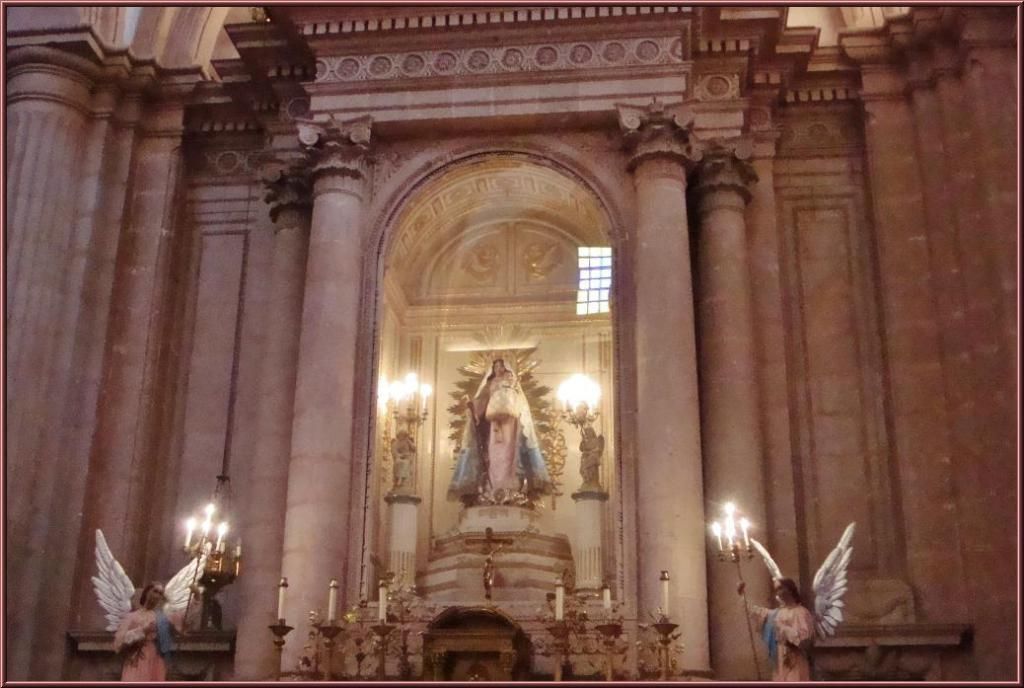What type of objects can be seen in the image? There are statues and candles on stands in the image. What architectural features are visible in the background? There are pillars and a wall visible in the background of the image. How much anger can be seen on the faces of the statues in the image? There are no faces on the statues in the image, so it is not possible to determine the amount of anger present. 